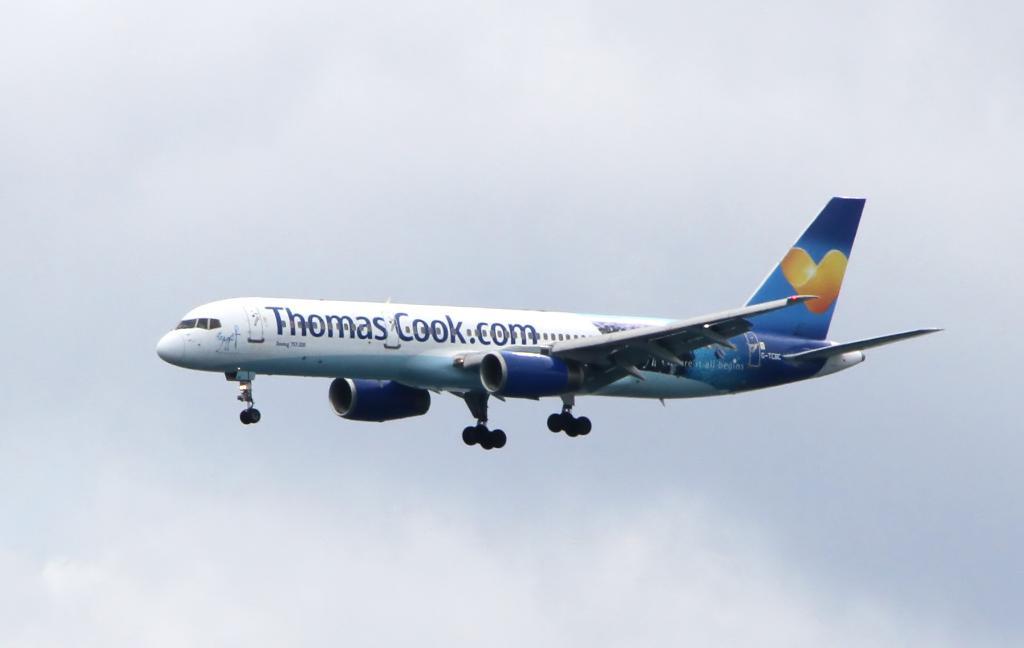Which website is being advertised?
Your answer should be compact. Thomascook.com. 